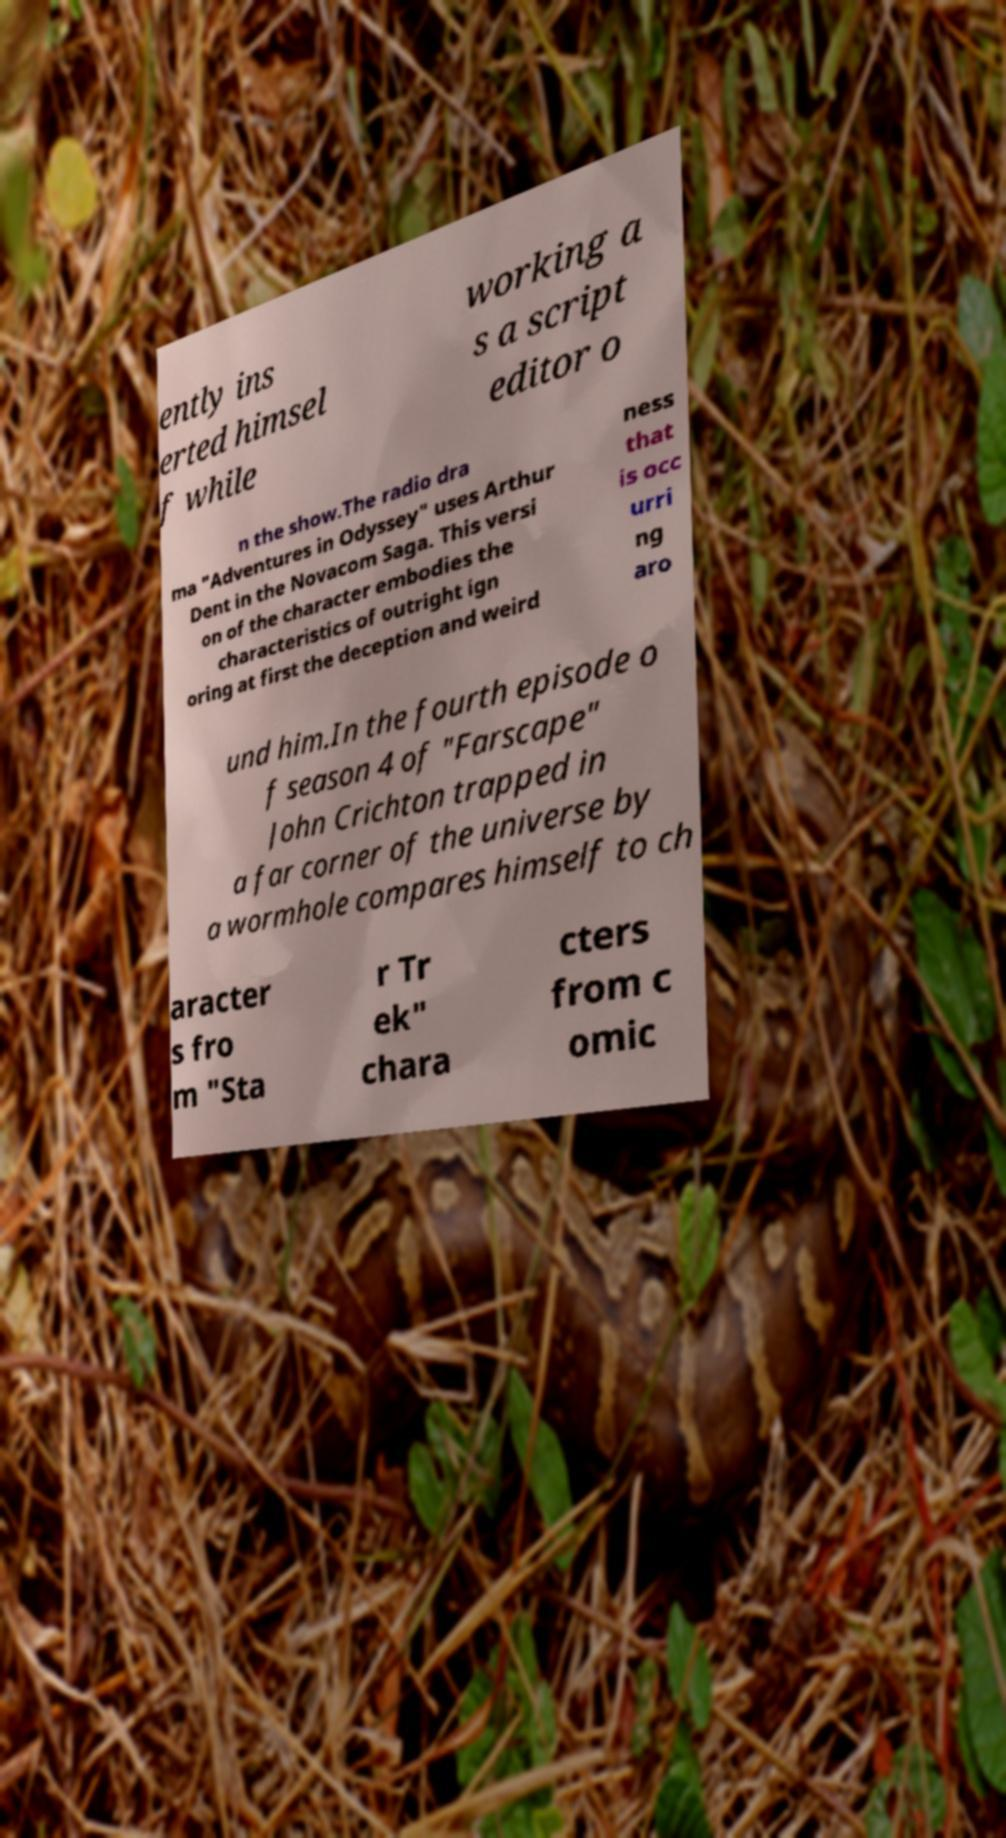There's text embedded in this image that I need extracted. Can you transcribe it verbatim? ently ins erted himsel f while working a s a script editor o n the show.The radio dra ma "Adventures in Odyssey" uses Arthur Dent in the Novacom Saga. This versi on of the character embodies the characteristics of outright ign oring at first the deception and weird ness that is occ urri ng aro und him.In the fourth episode o f season 4 of "Farscape" John Crichton trapped in a far corner of the universe by a wormhole compares himself to ch aracter s fro m "Sta r Tr ek" chara cters from c omic 